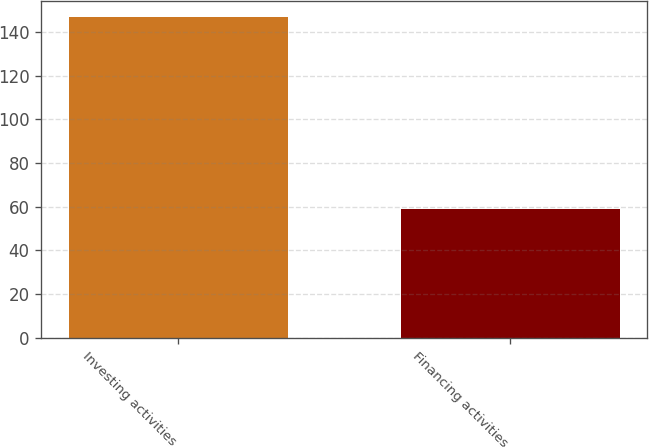Convert chart. <chart><loc_0><loc_0><loc_500><loc_500><bar_chart><fcel>Investing activities<fcel>Financing activities<nl><fcel>147<fcel>59<nl></chart> 